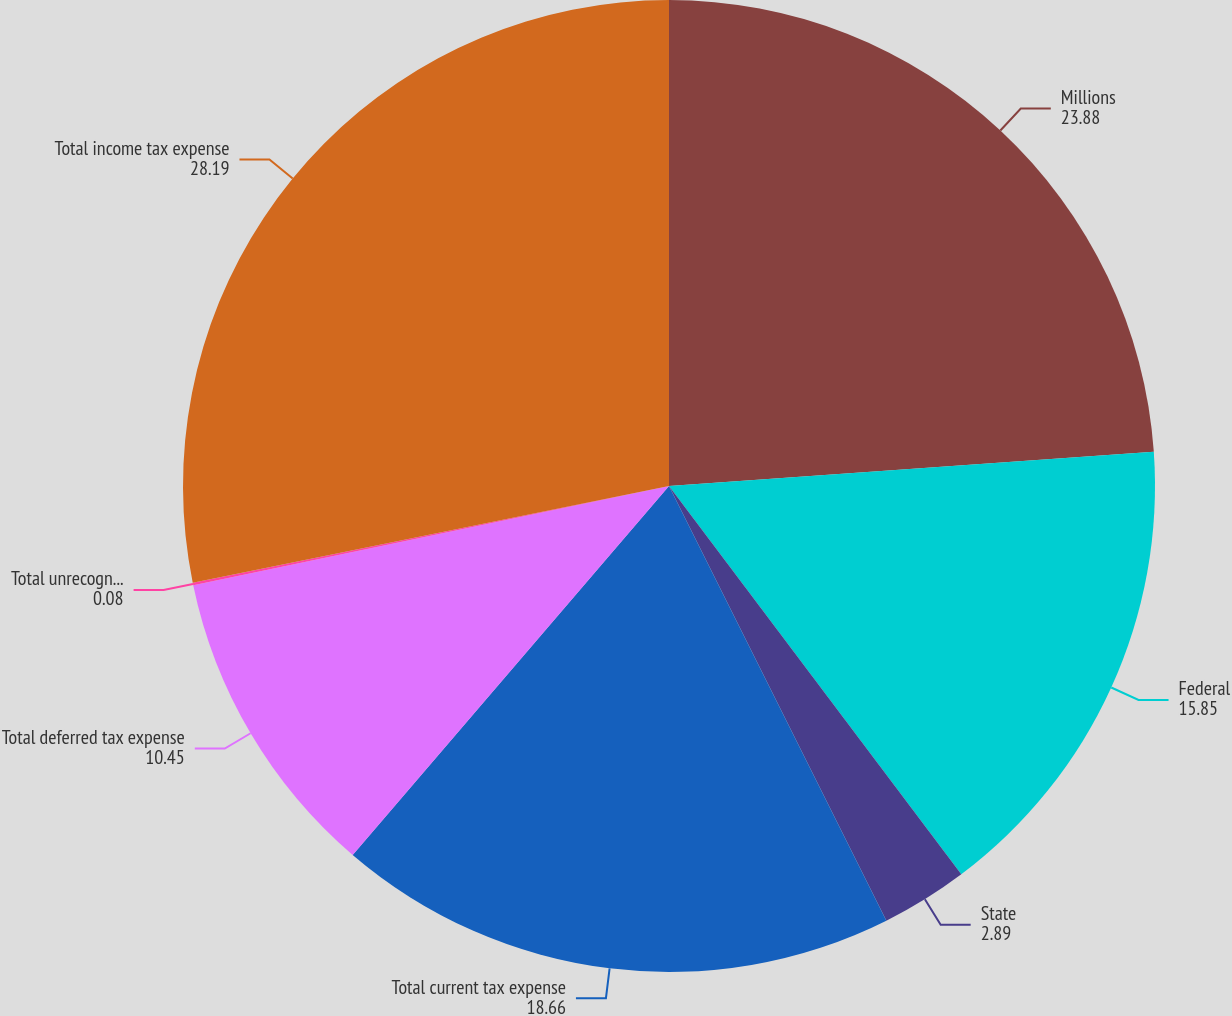Convert chart to OTSL. <chart><loc_0><loc_0><loc_500><loc_500><pie_chart><fcel>Millions<fcel>Federal<fcel>State<fcel>Total current tax expense<fcel>Total deferred tax expense<fcel>Total unrecognized tax<fcel>Total income tax expense<nl><fcel>23.88%<fcel>15.85%<fcel>2.89%<fcel>18.66%<fcel>10.45%<fcel>0.08%<fcel>28.19%<nl></chart> 